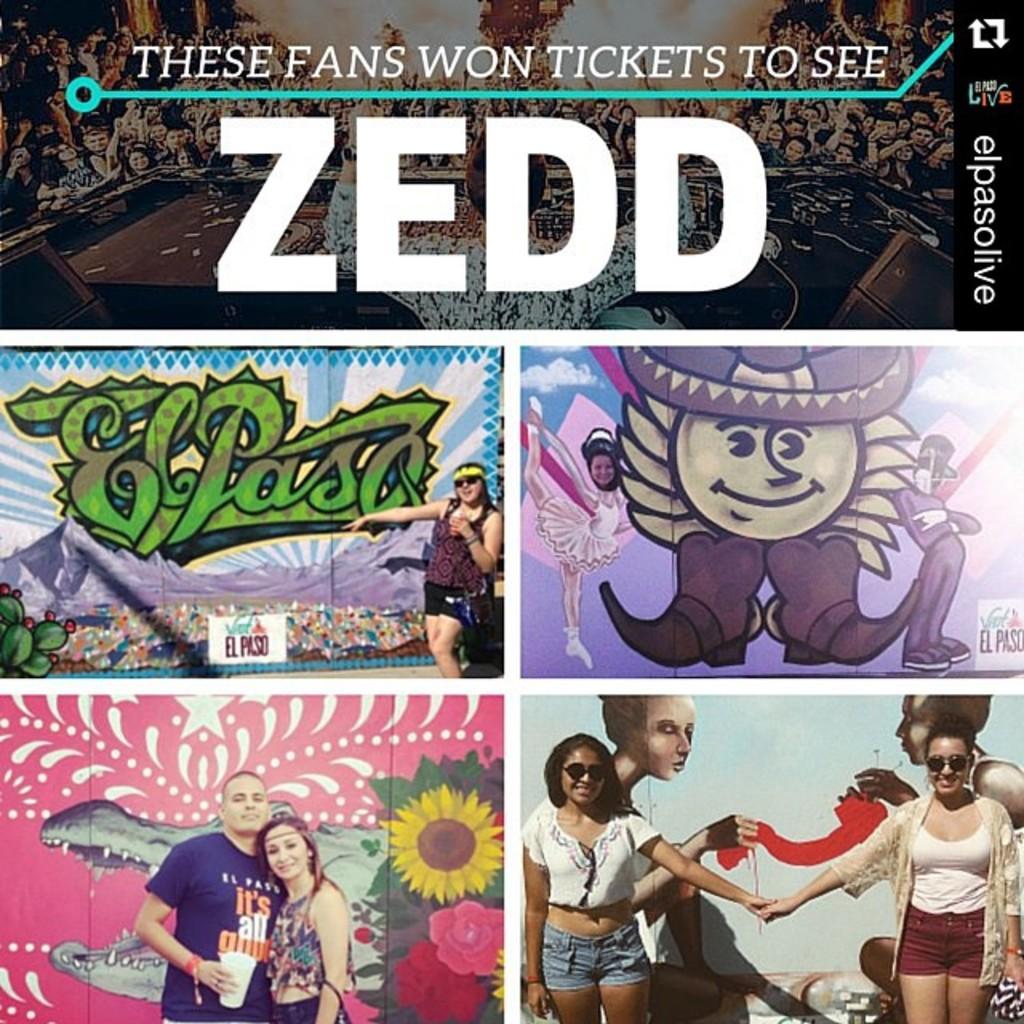Who did the fans win tickets to see?
Your answer should be very brief. Zedd. What town is featured on the cover?
Offer a very short reply. El paso. 